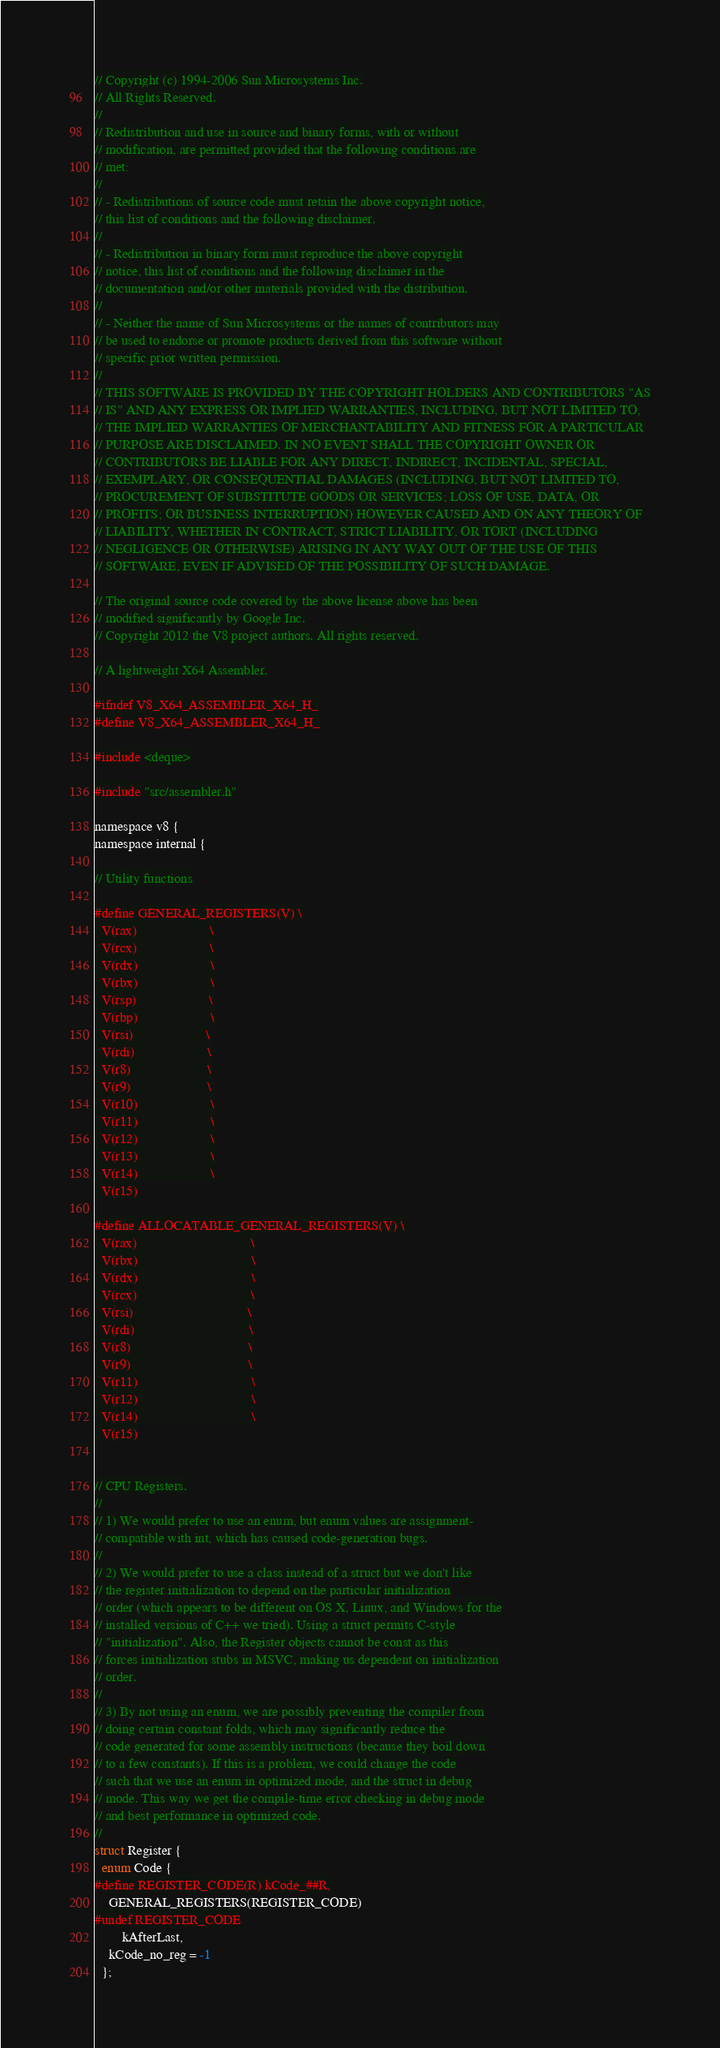Convert code to text. <code><loc_0><loc_0><loc_500><loc_500><_C_>// Copyright (c) 1994-2006 Sun Microsystems Inc.
// All Rights Reserved.
//
// Redistribution and use in source and binary forms, with or without
// modification, are permitted provided that the following conditions are
// met:
//
// - Redistributions of source code must retain the above copyright notice,
// this list of conditions and the following disclaimer.
//
// - Redistribution in binary form must reproduce the above copyright
// notice, this list of conditions and the following disclaimer in the
// documentation and/or other materials provided with the distribution.
//
// - Neither the name of Sun Microsystems or the names of contributors may
// be used to endorse or promote products derived from this software without
// specific prior written permission.
//
// THIS SOFTWARE IS PROVIDED BY THE COPYRIGHT HOLDERS AND CONTRIBUTORS "AS
// IS" AND ANY EXPRESS OR IMPLIED WARRANTIES, INCLUDING, BUT NOT LIMITED TO,
// THE IMPLIED WARRANTIES OF MERCHANTABILITY AND FITNESS FOR A PARTICULAR
// PURPOSE ARE DISCLAIMED. IN NO EVENT SHALL THE COPYRIGHT OWNER OR
// CONTRIBUTORS BE LIABLE FOR ANY DIRECT, INDIRECT, INCIDENTAL, SPECIAL,
// EXEMPLARY, OR CONSEQUENTIAL DAMAGES (INCLUDING, BUT NOT LIMITED TO,
// PROCUREMENT OF SUBSTITUTE GOODS OR SERVICES; LOSS OF USE, DATA, OR
// PROFITS; OR BUSINESS INTERRUPTION) HOWEVER CAUSED AND ON ANY THEORY OF
// LIABILITY, WHETHER IN CONTRACT, STRICT LIABILITY, OR TORT (INCLUDING
// NEGLIGENCE OR OTHERWISE) ARISING IN ANY WAY OUT OF THE USE OF THIS
// SOFTWARE, EVEN IF ADVISED OF THE POSSIBILITY OF SUCH DAMAGE.

// The original source code covered by the above license above has been
// modified significantly by Google Inc.
// Copyright 2012 the V8 project authors. All rights reserved.

// A lightweight X64 Assembler.

#ifndef V8_X64_ASSEMBLER_X64_H_
#define V8_X64_ASSEMBLER_X64_H_

#include <deque>

#include "src/assembler.h"

namespace v8 {
namespace internal {

// Utility functions

#define GENERAL_REGISTERS(V) \
  V(rax)                     \
  V(rcx)                     \
  V(rdx)                     \
  V(rbx)                     \
  V(rsp)                     \
  V(rbp)                     \
  V(rsi)                     \
  V(rdi)                     \
  V(r8)                      \
  V(r9)                      \
  V(r10)                     \
  V(r11)                     \
  V(r12)                     \
  V(r13)                     \
  V(r14)                     \
  V(r15)

#define ALLOCATABLE_GENERAL_REGISTERS(V) \
  V(rax)                                 \
  V(rbx)                                 \
  V(rdx)                                 \
  V(rcx)                                 \
  V(rsi)                                 \
  V(rdi)                                 \
  V(r8)                                  \
  V(r9)                                  \
  V(r11)                                 \
  V(r12)                                 \
  V(r14)                                 \
  V(r15)


// CPU Registers.
//
// 1) We would prefer to use an enum, but enum values are assignment-
// compatible with int, which has caused code-generation bugs.
//
// 2) We would prefer to use a class instead of a struct but we don't like
// the register initialization to depend on the particular initialization
// order (which appears to be different on OS X, Linux, and Windows for the
// installed versions of C++ we tried). Using a struct permits C-style
// "initialization". Also, the Register objects cannot be const as this
// forces initialization stubs in MSVC, making us dependent on initialization
// order.
//
// 3) By not using an enum, we are possibly preventing the compiler from
// doing certain constant folds, which may significantly reduce the
// code generated for some assembly instructions (because they boil down
// to a few constants). If this is a problem, we could change the code
// such that we use an enum in optimized mode, and the struct in debug
// mode. This way we get the compile-time error checking in debug mode
// and best performance in optimized code.
//
struct Register {
  enum Code {
#define REGISTER_CODE(R) kCode_##R,
    GENERAL_REGISTERS(REGISTER_CODE)
#undef REGISTER_CODE
        kAfterLast,
    kCode_no_reg = -1
  };
</code> 